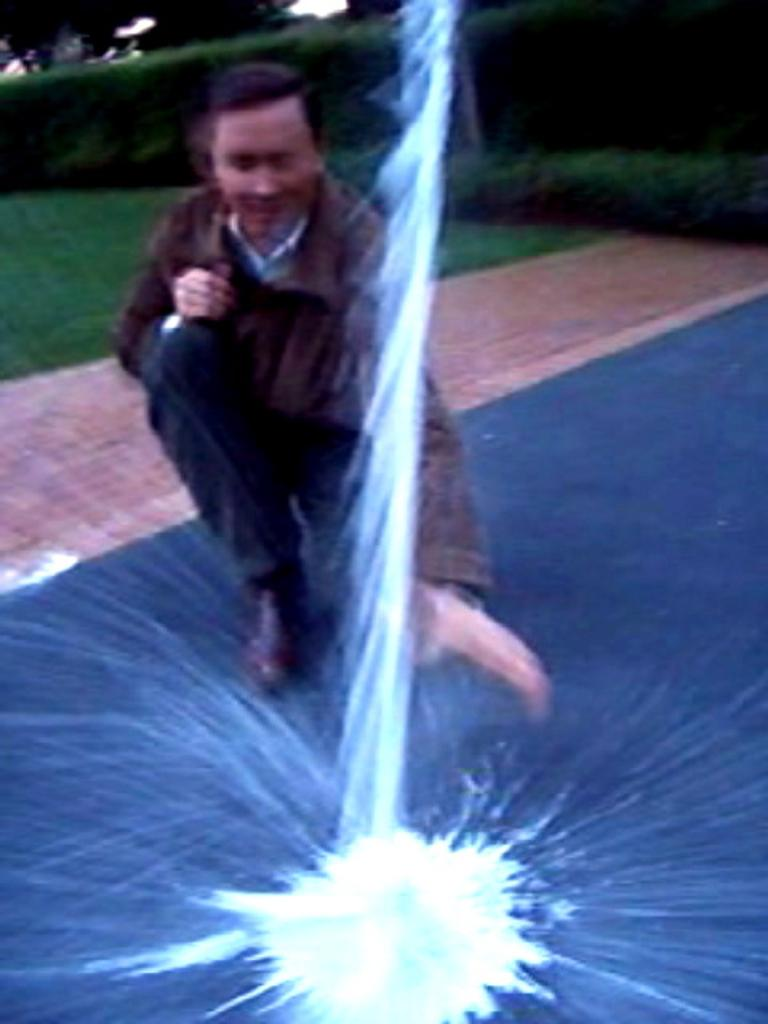Who or what is the main subject in the center of the image? There is a person in the center of the image. What is located in the foreground of the image? There is some powder in the foreground of the image. What type of vegetation can be seen in the background of the image? There are plants and grass in the background of the image. What type of surface is visible in the background of the image? There is a pavement in the background of the image. What type of coal is being used to support the beam in the image? There is no coal or beam present in the image. How is the person in the image blowing out the candles? There is no indication of candles or blowing in the image. 